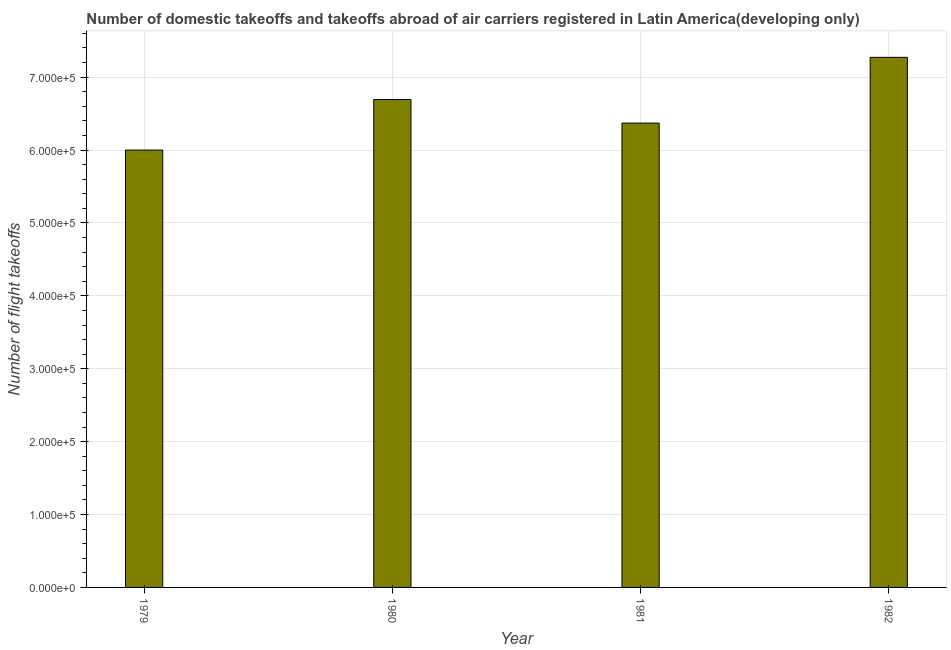Does the graph contain any zero values?
Make the answer very short. No. What is the title of the graph?
Keep it short and to the point. Number of domestic takeoffs and takeoffs abroad of air carriers registered in Latin America(developing only). What is the label or title of the X-axis?
Your response must be concise. Year. What is the label or title of the Y-axis?
Your answer should be very brief. Number of flight takeoffs. What is the number of flight takeoffs in 1982?
Make the answer very short. 7.27e+05. Across all years, what is the maximum number of flight takeoffs?
Offer a terse response. 7.27e+05. In which year was the number of flight takeoffs minimum?
Offer a very short reply. 1979. What is the sum of the number of flight takeoffs?
Your answer should be very brief. 2.63e+06. What is the difference between the number of flight takeoffs in 1979 and 1980?
Your answer should be very brief. -6.93e+04. What is the average number of flight takeoffs per year?
Provide a succinct answer. 6.58e+05. What is the median number of flight takeoffs?
Make the answer very short. 6.53e+05. Do a majority of the years between 1982 and 1981 (inclusive) have number of flight takeoffs greater than 80000 ?
Ensure brevity in your answer.  No. What is the ratio of the number of flight takeoffs in 1980 to that in 1981?
Your answer should be very brief. 1.05. Is the number of flight takeoffs in 1979 less than that in 1981?
Offer a terse response. Yes. Is the difference between the number of flight takeoffs in 1979 and 1982 greater than the difference between any two years?
Keep it short and to the point. Yes. What is the difference between the highest and the second highest number of flight takeoffs?
Provide a short and direct response. 5.79e+04. Is the sum of the number of flight takeoffs in 1981 and 1982 greater than the maximum number of flight takeoffs across all years?
Offer a terse response. Yes. What is the difference between the highest and the lowest number of flight takeoffs?
Give a very brief answer. 1.27e+05. In how many years, is the number of flight takeoffs greater than the average number of flight takeoffs taken over all years?
Ensure brevity in your answer.  2. How many bars are there?
Your response must be concise. 4. Are all the bars in the graph horizontal?
Provide a short and direct response. No. What is the Number of flight takeoffs in 1979?
Make the answer very short. 6.00e+05. What is the Number of flight takeoffs of 1980?
Ensure brevity in your answer.  6.69e+05. What is the Number of flight takeoffs of 1981?
Ensure brevity in your answer.  6.37e+05. What is the Number of flight takeoffs of 1982?
Keep it short and to the point. 7.27e+05. What is the difference between the Number of flight takeoffs in 1979 and 1980?
Your response must be concise. -6.93e+04. What is the difference between the Number of flight takeoffs in 1979 and 1981?
Make the answer very short. -3.70e+04. What is the difference between the Number of flight takeoffs in 1979 and 1982?
Provide a short and direct response. -1.27e+05. What is the difference between the Number of flight takeoffs in 1980 and 1981?
Your answer should be very brief. 3.23e+04. What is the difference between the Number of flight takeoffs in 1980 and 1982?
Keep it short and to the point. -5.79e+04. What is the difference between the Number of flight takeoffs in 1981 and 1982?
Make the answer very short. -9.02e+04. What is the ratio of the Number of flight takeoffs in 1979 to that in 1980?
Give a very brief answer. 0.9. What is the ratio of the Number of flight takeoffs in 1979 to that in 1981?
Your response must be concise. 0.94. What is the ratio of the Number of flight takeoffs in 1979 to that in 1982?
Make the answer very short. 0.82. What is the ratio of the Number of flight takeoffs in 1980 to that in 1981?
Your response must be concise. 1.05. What is the ratio of the Number of flight takeoffs in 1980 to that in 1982?
Provide a succinct answer. 0.92. What is the ratio of the Number of flight takeoffs in 1981 to that in 1982?
Your answer should be very brief. 0.88. 